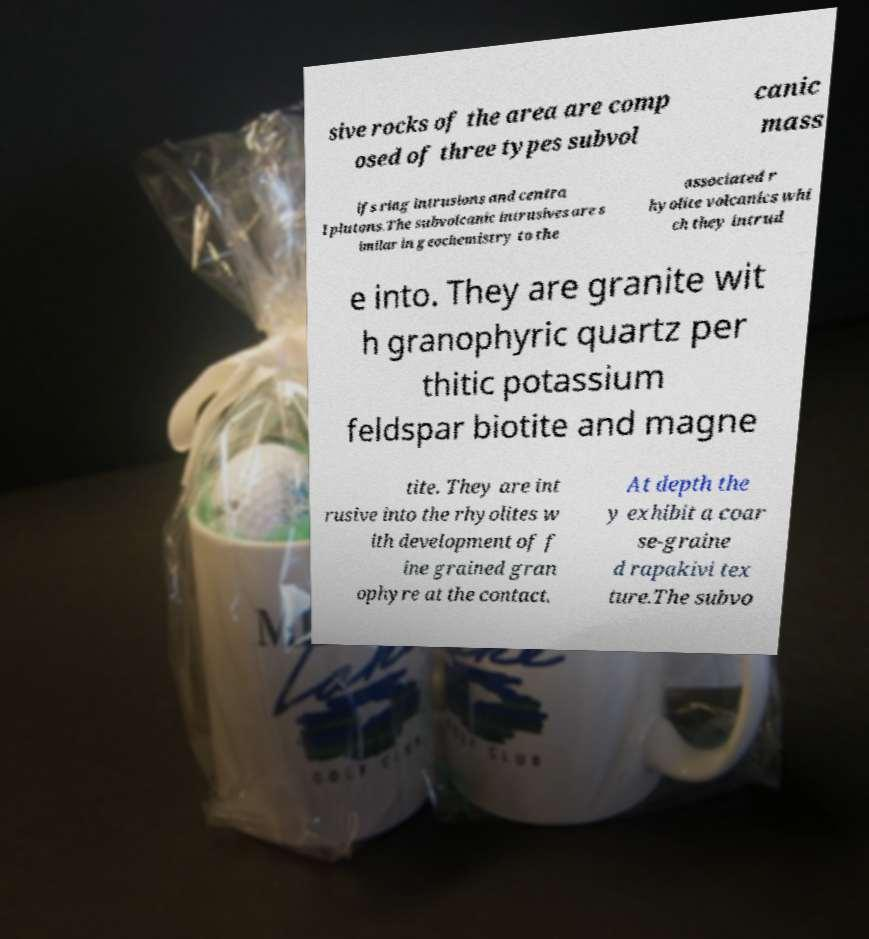Could you assist in decoding the text presented in this image and type it out clearly? sive rocks of the area are comp osed of three types subvol canic mass ifs ring intrusions and centra l plutons.The subvolcanic intrusives are s imilar in geochemistry to the associated r hyolite volcanics whi ch they intrud e into. They are granite wit h granophyric quartz per thitic potassium feldspar biotite and magne tite. They are int rusive into the rhyolites w ith development of f ine grained gran ophyre at the contact. At depth the y exhibit a coar se-graine d rapakivi tex ture.The subvo 